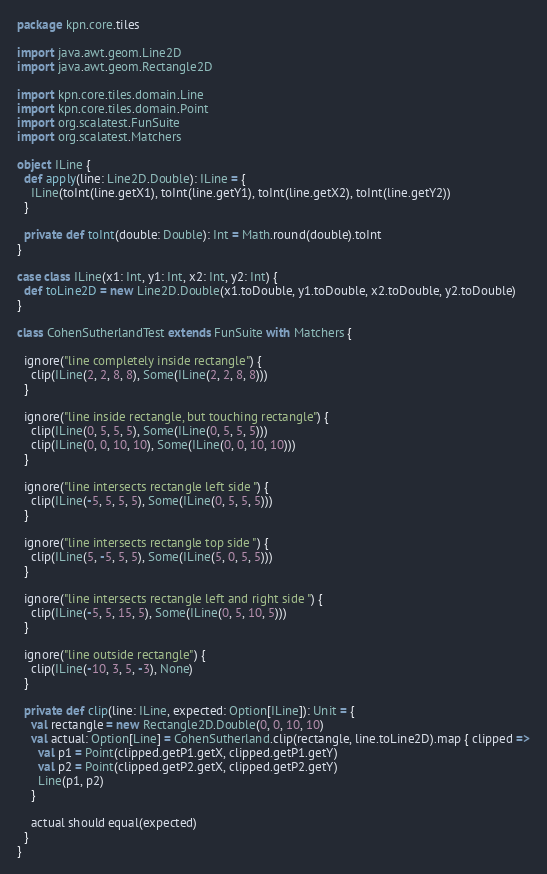Convert code to text. <code><loc_0><loc_0><loc_500><loc_500><_Scala_>package kpn.core.tiles

import java.awt.geom.Line2D
import java.awt.geom.Rectangle2D

import kpn.core.tiles.domain.Line
import kpn.core.tiles.domain.Point
import org.scalatest.FunSuite
import org.scalatest.Matchers

object ILine {
  def apply(line: Line2D.Double): ILine = {
    ILine(toInt(line.getX1), toInt(line.getY1), toInt(line.getX2), toInt(line.getY2))
  }

  private def toInt(double: Double): Int = Math.round(double).toInt
}

case class ILine(x1: Int, y1: Int, x2: Int, y2: Int) {
  def toLine2D = new Line2D.Double(x1.toDouble, y1.toDouble, x2.toDouble, y2.toDouble)
}

class CohenSutherlandTest extends FunSuite with Matchers {

  ignore("line completely inside rectangle") {
    clip(ILine(2, 2, 8, 8), Some(ILine(2, 2, 8, 8)))
  }

  ignore("line inside rectangle, but touching rectangle") {
    clip(ILine(0, 5, 5, 5), Some(ILine(0, 5, 5, 5)))
    clip(ILine(0, 0, 10, 10), Some(ILine(0, 0, 10, 10)))
  }

  ignore("line intersects rectangle left side ") {
    clip(ILine(-5, 5, 5, 5), Some(ILine(0, 5, 5, 5)))
  }

  ignore("line intersects rectangle top side ") {
    clip(ILine(5, -5, 5, 5), Some(ILine(5, 0, 5, 5)))
  }

  ignore("line intersects rectangle left and right side ") {
    clip(ILine(-5, 5, 15, 5), Some(ILine(0, 5, 10, 5)))
  }

  ignore("line outside rectangle") {
    clip(ILine(-10, 3, 5, -3), None)
  }

  private def clip(line: ILine, expected: Option[ILine]): Unit = {
    val rectangle = new Rectangle2D.Double(0, 0, 10, 10)
    val actual: Option[Line] = CohenSutherland.clip(rectangle, line.toLine2D).map { clipped =>
      val p1 = Point(clipped.getP1.getX, clipped.getP1.getY)
      val p2 = Point(clipped.getP2.getX, clipped.getP2.getY)
      Line(p1, p2)
    }

    actual should equal(expected)
  }
}
</code> 